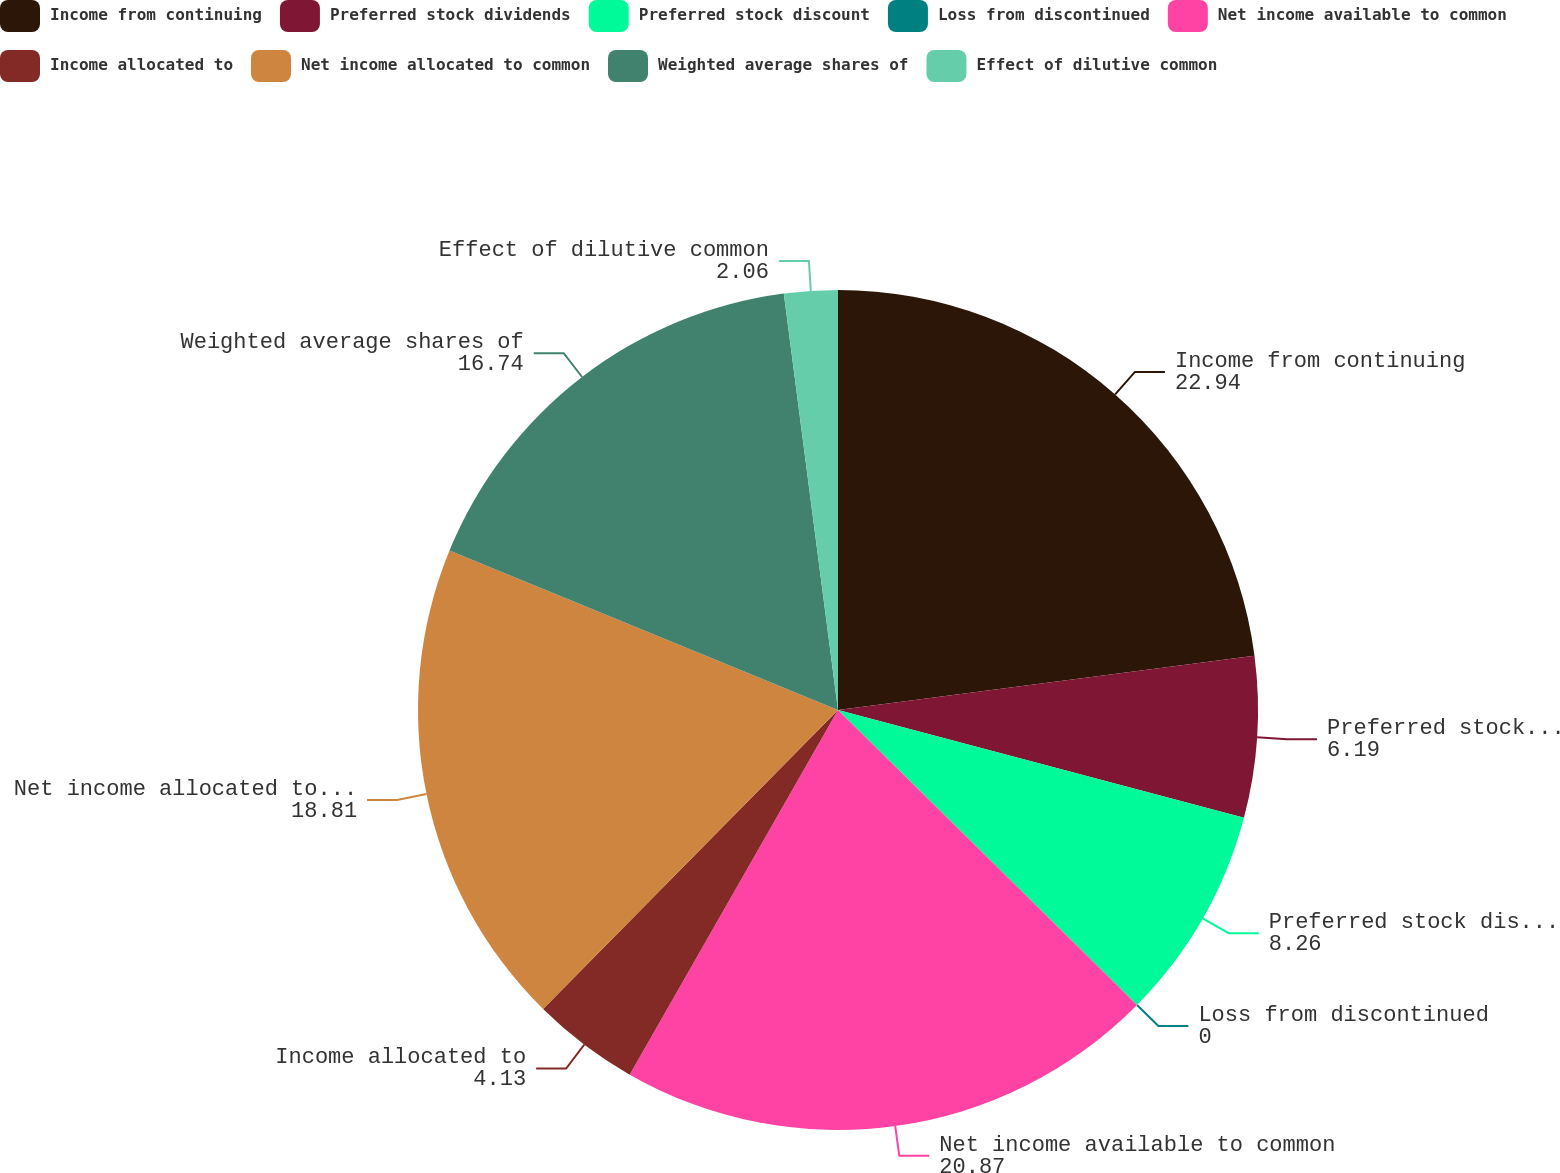Convert chart to OTSL. <chart><loc_0><loc_0><loc_500><loc_500><pie_chart><fcel>Income from continuing<fcel>Preferred stock dividends<fcel>Preferred stock discount<fcel>Loss from discontinued<fcel>Net income available to common<fcel>Income allocated to<fcel>Net income allocated to common<fcel>Weighted average shares of<fcel>Effect of dilutive common<nl><fcel>22.94%<fcel>6.19%<fcel>8.26%<fcel>0.0%<fcel>20.87%<fcel>4.13%<fcel>18.81%<fcel>16.74%<fcel>2.06%<nl></chart> 